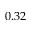<formula> <loc_0><loc_0><loc_500><loc_500>0 . 3 2</formula> 